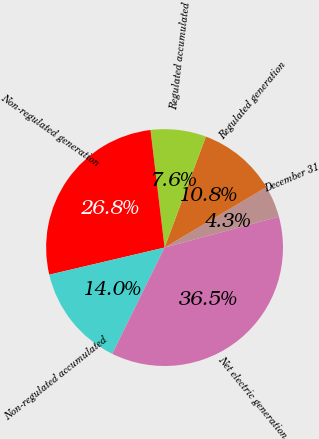Convert chart. <chart><loc_0><loc_0><loc_500><loc_500><pie_chart><fcel>December 31<fcel>Regulated generation<fcel>Regulated accumulated<fcel>Non-regulated generation<fcel>Non-regulated accumulated<fcel>Net electric generation<nl><fcel>4.33%<fcel>10.8%<fcel>7.57%<fcel>26.78%<fcel>14.04%<fcel>36.48%<nl></chart> 